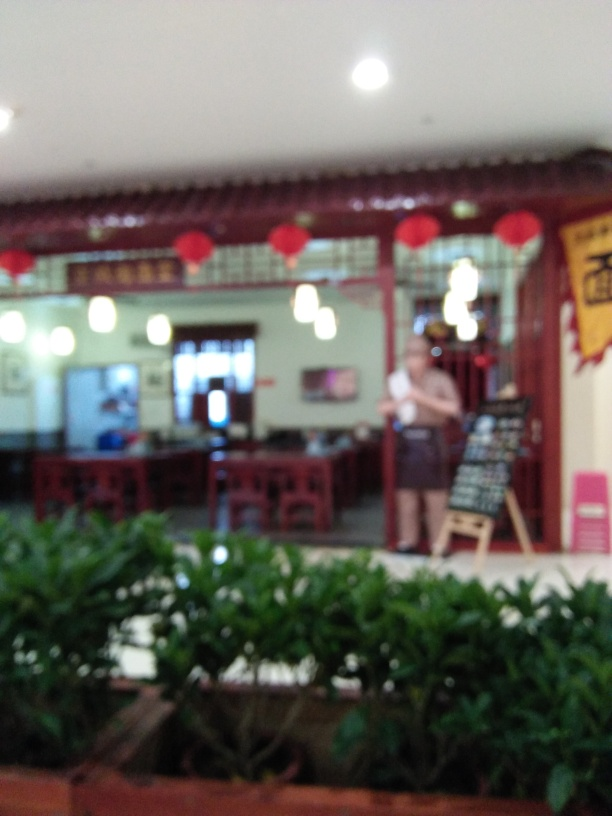Is there a significant loss of texture details in the image? Indeed, the image exhibits a noticeable loss of texture, likely due to motion blur or a focus issue while taking the picture. This effect particularly impacts the finer details, rendering elements such as text, individual objects, and facial features indiscernible. Restoring clarity might require a re-capture or advanced image processing techniques. 